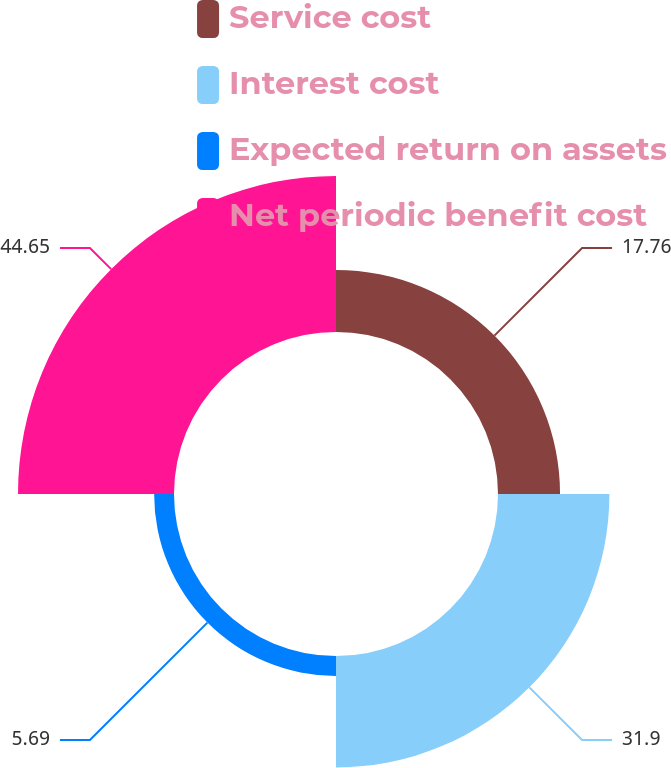Convert chart to OTSL. <chart><loc_0><loc_0><loc_500><loc_500><pie_chart><fcel>Service cost<fcel>Interest cost<fcel>Expected return on assets<fcel>Net periodic benefit cost<nl><fcel>17.76%<fcel>31.9%<fcel>5.69%<fcel>44.66%<nl></chart> 